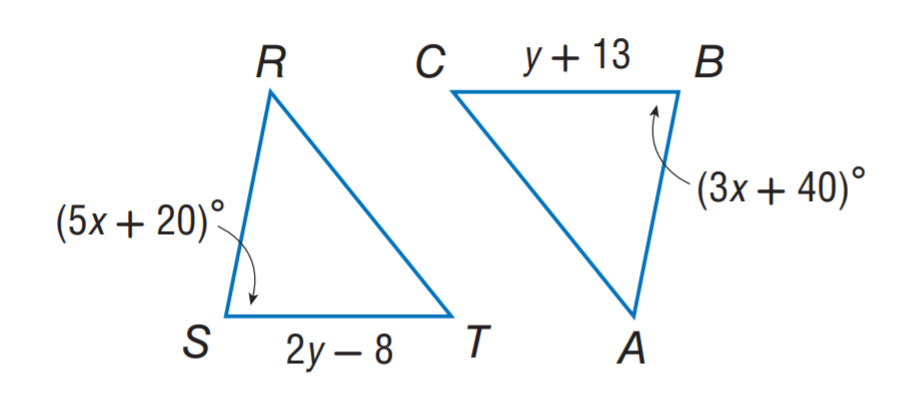Answer the mathemtical geometry problem and directly provide the correct option letter.
Question: \triangle R S T \cong \triangle A B C. Find y.
Choices: A: 13 B: 21 C: 31 D: 40 B 